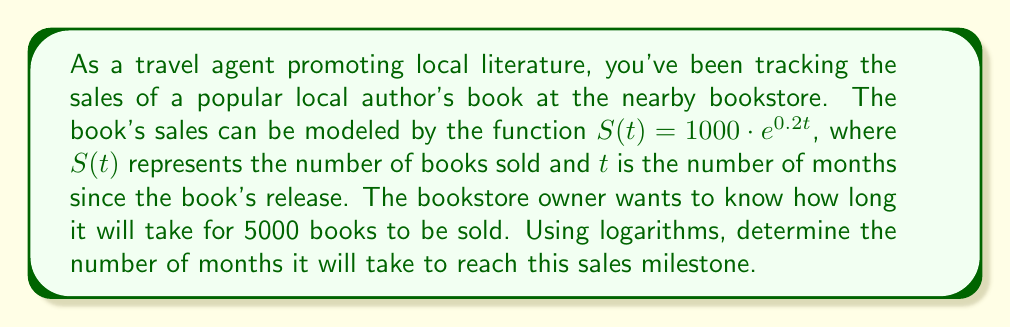Can you solve this math problem? To solve this problem, we'll use the given exponential function and apply logarithms to isolate the time variable. Here's a step-by-step approach:

1) We start with the given function: $S(t) = 1000 \cdot e^{0.2t}$

2) We want to find $t$ when $S(t) = 5000$. So, let's set up the equation:
   
   $5000 = 1000 \cdot e^{0.2t}$

3) First, divide both sides by 1000:
   
   $5 = e^{0.2t}$

4) Now, we can apply the natural logarithm (ln) to both sides. Remember, $\ln(e^x) = x$:
   
   $\ln(5) = \ln(e^{0.2t})$
   $\ln(5) = 0.2t$

5) Finally, we can solve for $t$ by dividing both sides by 0.2:
   
   $t = \frac{\ln(5)}{0.2}$

6) Using a calculator or computer, we can evaluate this:
   
   $t \approx 8.0472$

Since we're dealing with months, we should round up to the nearest whole month.
Answer: It will take 9 months for 5000 books to be sold. 